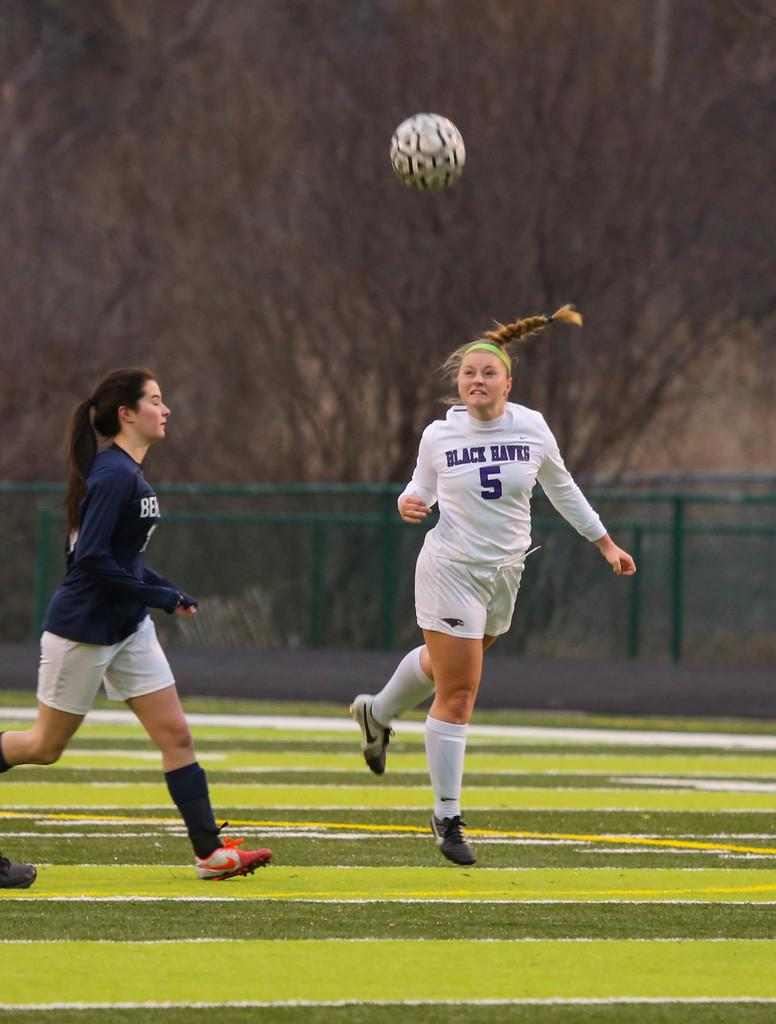How many people are in the image? There are people in the image, but the exact number is not specified. What are the people doing in the image? The people are on the ground, which suggests they might be playing or engaging in some activity. What type of surface is the ground made of? The ground has grass, indicating it is an outdoor setting. What is happening with the ball in the image? There is a ball in the air, which suggests it is being kicked or thrown. What can be seen in the background of the image? The background is blurred, so it is difficult to make out specific details. How many sheep are visible in the image? There are no sheep present in the image. Can you describe the self in the image? There is no self or person taking a selfie in the image. 